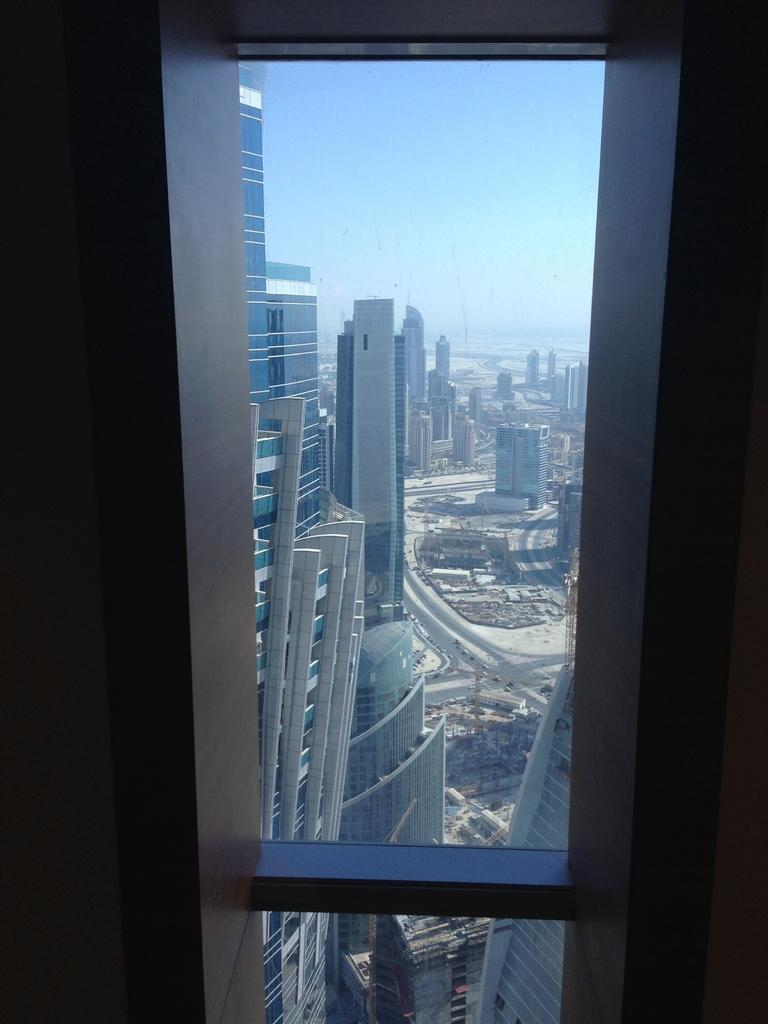Where was the image taken? The image is taken indoors. What can be seen in the center of the image? There is a window in the center of the image. What is visible through the window? The sky, skyscrapers, buildings, vehicles, and other objects are visible through the window. Can you tell me how many monkeys are sitting on the liquid in the image? There are no monkeys or liquid present in the image. 